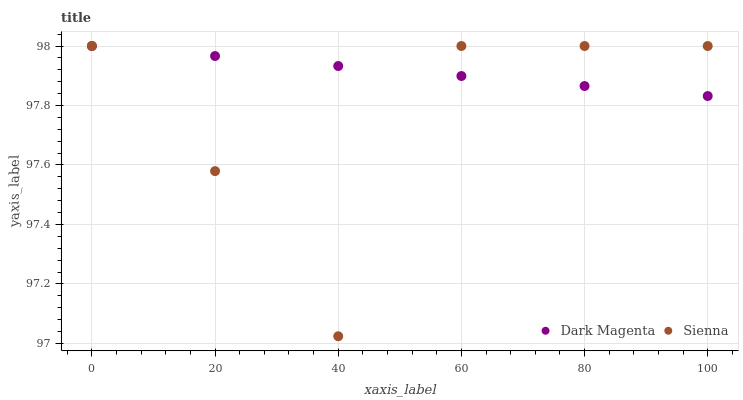Does Sienna have the minimum area under the curve?
Answer yes or no. Yes. Does Dark Magenta have the maximum area under the curve?
Answer yes or no. Yes. Does Dark Magenta have the minimum area under the curve?
Answer yes or no. No. Is Dark Magenta the smoothest?
Answer yes or no. Yes. Is Sienna the roughest?
Answer yes or no. Yes. Is Dark Magenta the roughest?
Answer yes or no. No. Does Sienna have the lowest value?
Answer yes or no. Yes. Does Dark Magenta have the lowest value?
Answer yes or no. No. Does Dark Magenta have the highest value?
Answer yes or no. Yes. Does Sienna intersect Dark Magenta?
Answer yes or no. Yes. Is Sienna less than Dark Magenta?
Answer yes or no. No. Is Sienna greater than Dark Magenta?
Answer yes or no. No. 